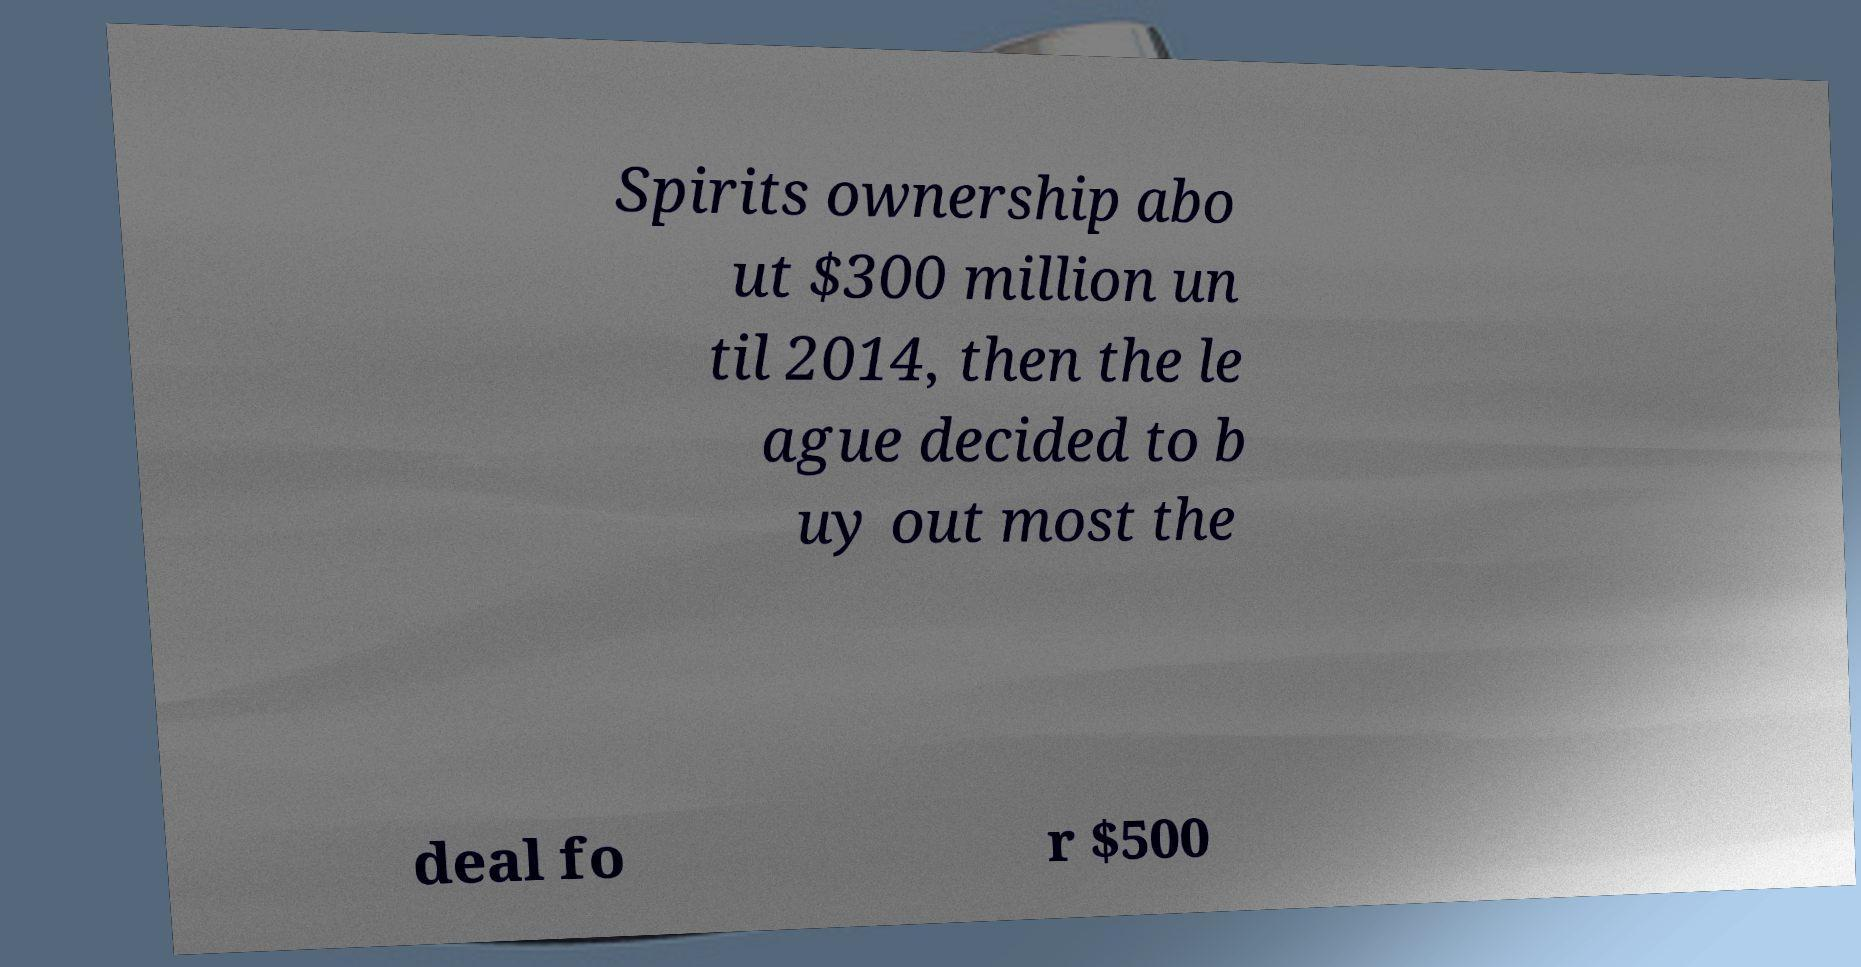Could you extract and type out the text from this image? Spirits ownership abo ut $300 million un til 2014, then the le ague decided to b uy out most the deal fo r $500 